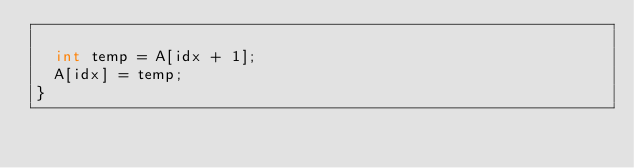<code> <loc_0><loc_0><loc_500><loc_500><_Cuda_>
  int temp = A[idx + 1];
  A[idx] = temp;
}</code> 